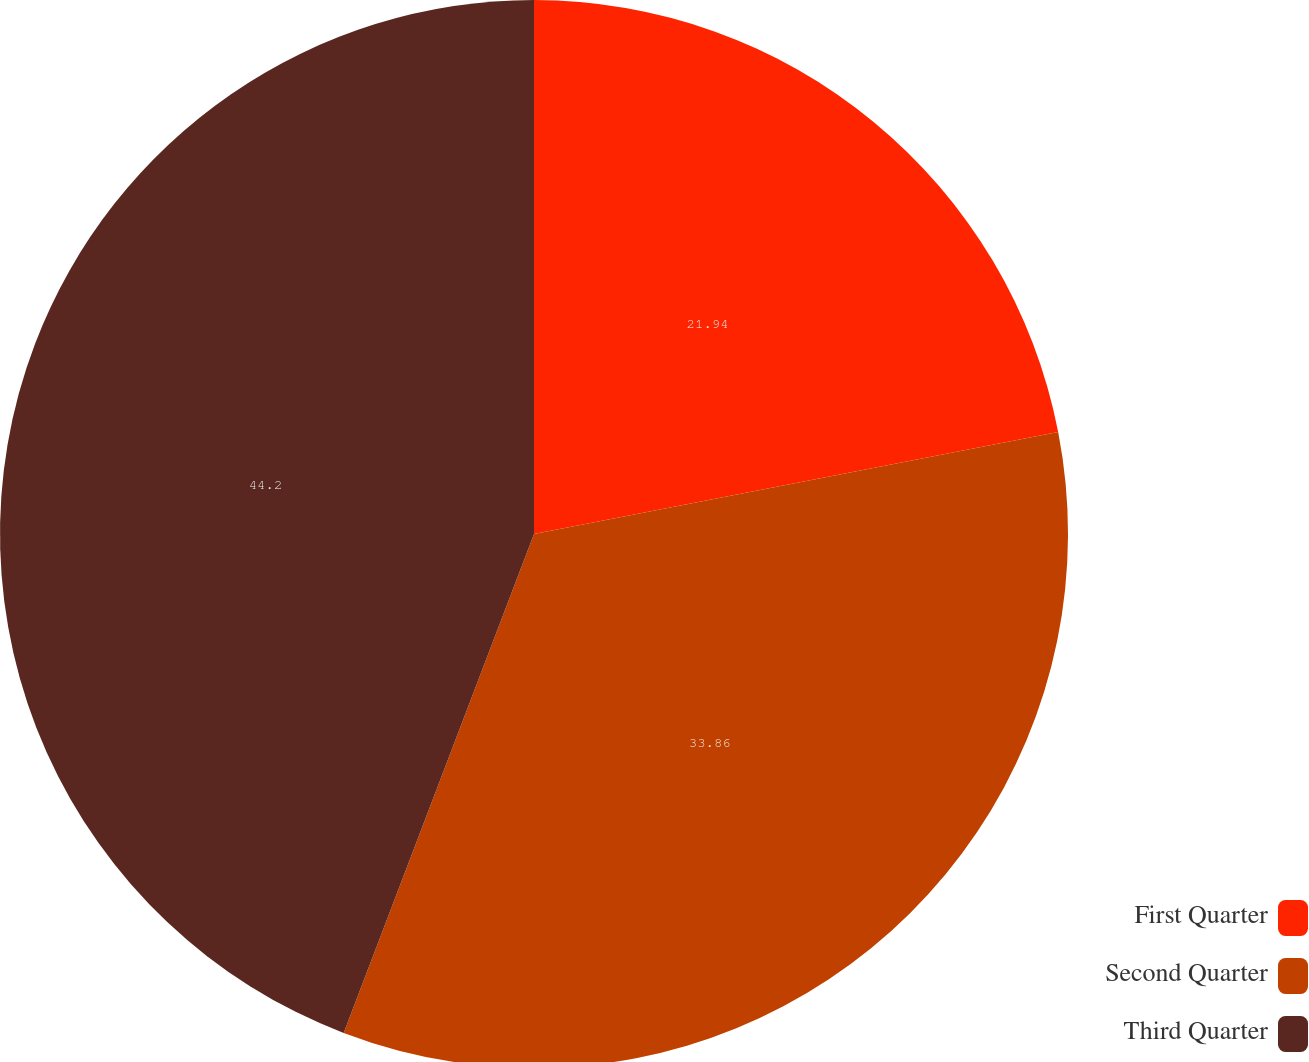Convert chart. <chart><loc_0><loc_0><loc_500><loc_500><pie_chart><fcel>First Quarter<fcel>Second Quarter<fcel>Third Quarter<nl><fcel>21.94%<fcel>33.86%<fcel>44.2%<nl></chart> 